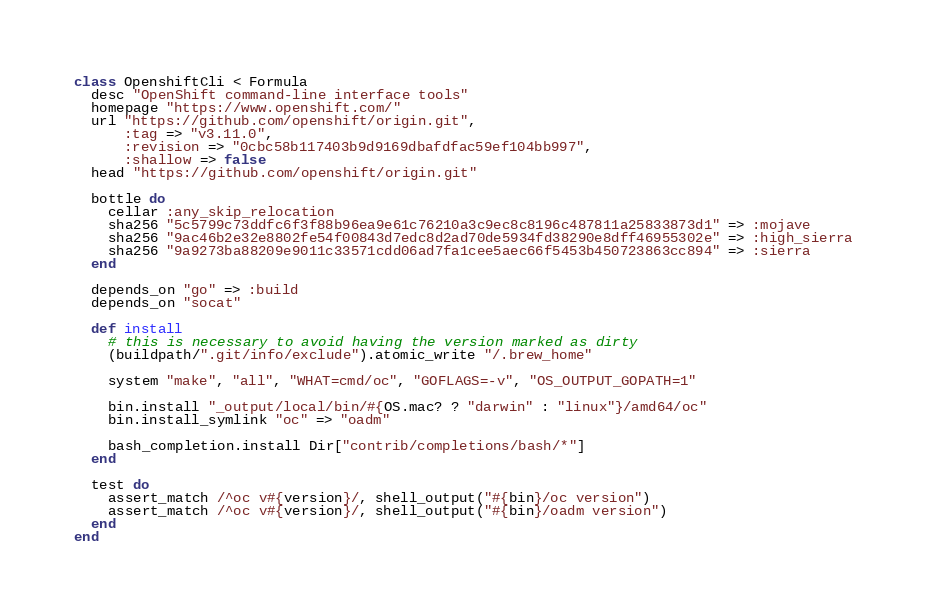<code> <loc_0><loc_0><loc_500><loc_500><_Ruby_>class OpenshiftCli < Formula
  desc "OpenShift command-line interface tools"
  homepage "https://www.openshift.com/"
  url "https://github.com/openshift/origin.git",
      :tag => "v3.11.0",
      :revision => "0cbc58b117403b9d9169dbafdfac59ef104bb997",
      :shallow => false
  head "https://github.com/openshift/origin.git"

  bottle do
    cellar :any_skip_relocation
    sha256 "5c5799c73ddfc6f3f88b96ea9e61c76210a3c9ec8c8196c487811a25833873d1" => :mojave
    sha256 "9ac46b2e32e8802fe54f00843d7edc8d2ad70de5934fd38290e8dff46955302e" => :high_sierra
    sha256 "9a9273ba88209e9011c33571cdd06ad7fa1cee5aec66f5453b450723863cc894" => :sierra
  end

  depends_on "go" => :build
  depends_on "socat"

  def install
    # this is necessary to avoid having the version marked as dirty
    (buildpath/".git/info/exclude").atomic_write "/.brew_home"

    system "make", "all", "WHAT=cmd/oc", "GOFLAGS=-v", "OS_OUTPUT_GOPATH=1"

    bin.install "_output/local/bin/#{OS.mac? ? "darwin" : "linux"}/amd64/oc"
    bin.install_symlink "oc" => "oadm"

    bash_completion.install Dir["contrib/completions/bash/*"]
  end

  test do
    assert_match /^oc v#{version}/, shell_output("#{bin}/oc version")
    assert_match /^oc v#{version}/, shell_output("#{bin}/oadm version")
  end
end
</code> 